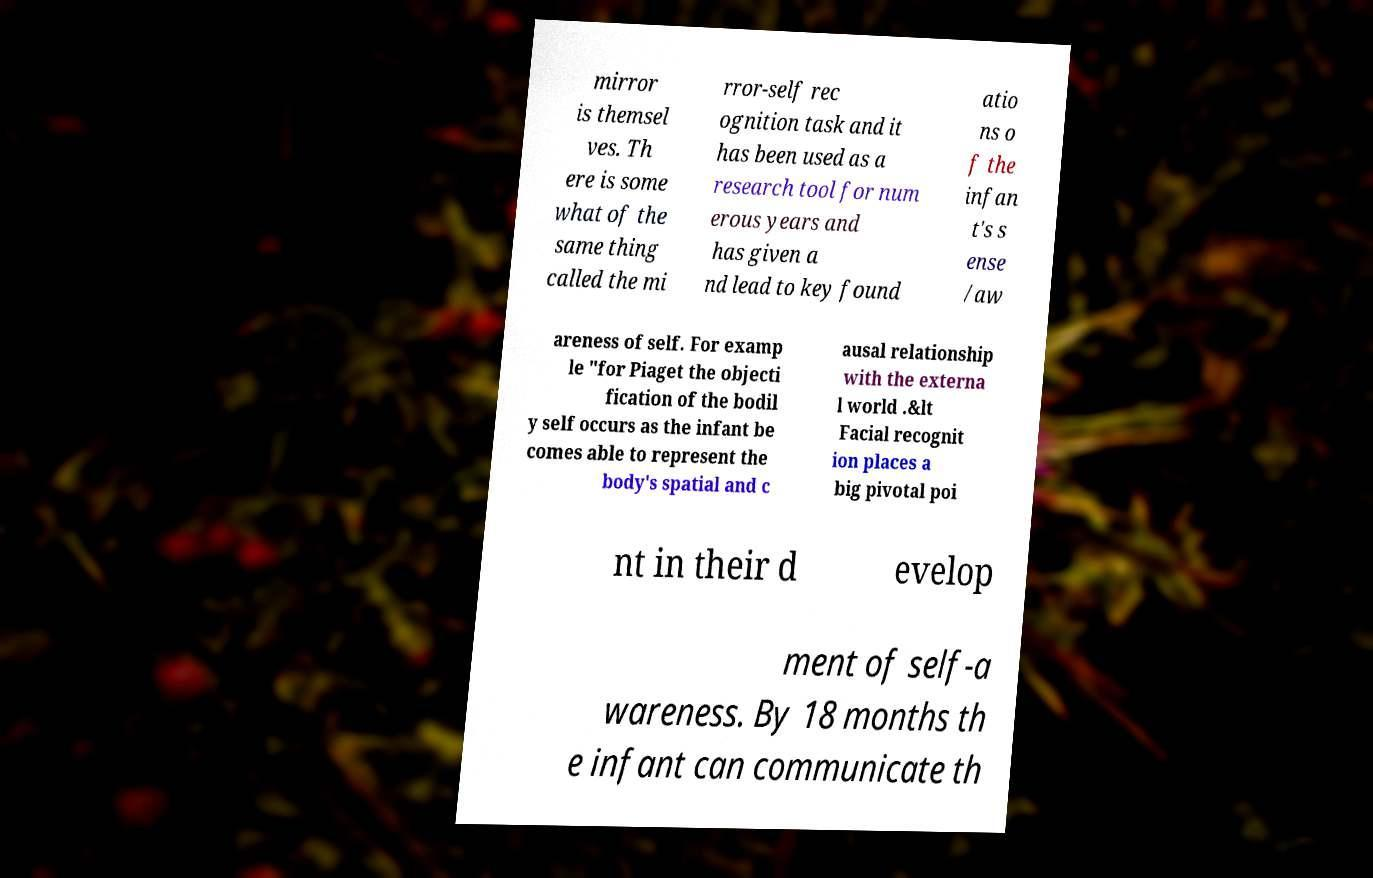There's text embedded in this image that I need extracted. Can you transcribe it verbatim? mirror is themsel ves. Th ere is some what of the same thing called the mi rror-self rec ognition task and it has been used as a research tool for num erous years and has given a nd lead to key found atio ns o f the infan t's s ense /aw areness of self. For examp le "for Piaget the objecti fication of the bodil y self occurs as the infant be comes able to represent the body's spatial and c ausal relationship with the externa l world .&lt Facial recognit ion places a big pivotal poi nt in their d evelop ment of self-a wareness. By 18 months th e infant can communicate th 